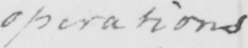Can you tell me what this handwritten text says? operations 